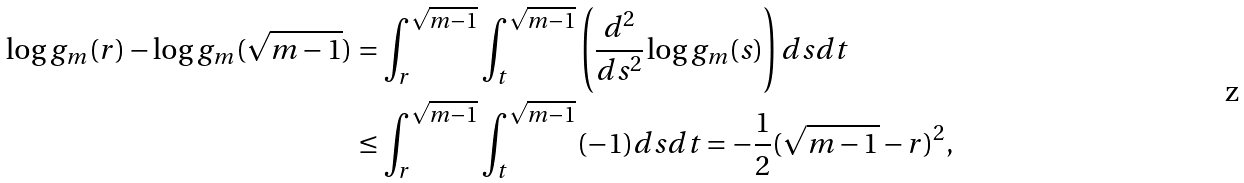Convert formula to latex. <formula><loc_0><loc_0><loc_500><loc_500>\log g _ { m } ( r ) - \log g _ { m } ( \sqrt { m - 1 } ) & = \int _ { r } ^ { \sqrt { m - 1 } } \int _ { t } ^ { \sqrt { m - 1 } } \left ( \frac { d ^ { 2 } } { d s ^ { 2 } } \log g _ { m } ( s ) \right ) d s d t \\ & \leq \int _ { r } ^ { \sqrt { m - 1 } } \int _ { t } ^ { \sqrt { m - 1 } } ( - 1 ) d s d t = - \frac { 1 } { 2 } ( \sqrt { m - 1 } - r ) ^ { 2 } ,</formula> 